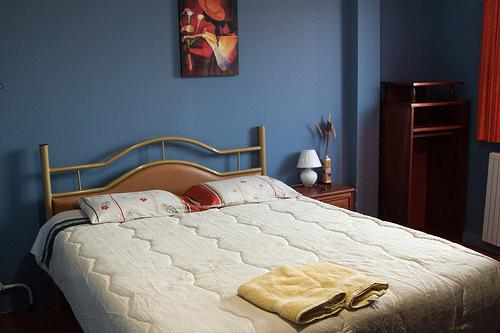Question: where are the towels?
Choices:
A. In the bathroom.
B. On the floor.
C. On the bed.
D. In the closet.
Answer with the letter. Answer: C Question: how many towels are in this picture?
Choices:
A. One.
B. Four.
C. Three.
D. Two.
Answer with the letter. Answer: D 